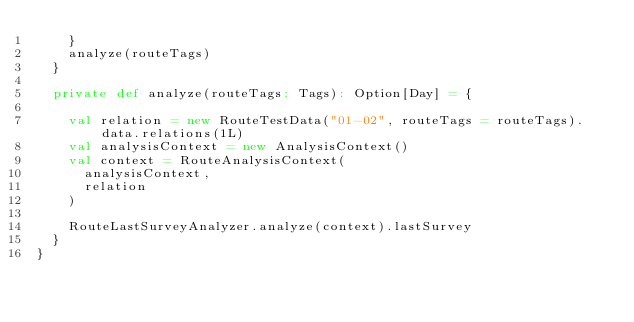Convert code to text. <code><loc_0><loc_0><loc_500><loc_500><_Scala_>    }
    analyze(routeTags)
  }

  private def analyze(routeTags: Tags): Option[Day] = {

    val relation = new RouteTestData("01-02", routeTags = routeTags).data.relations(1L)
    val analysisContext = new AnalysisContext()
    val context = RouteAnalysisContext(
      analysisContext,
      relation
    )

    RouteLastSurveyAnalyzer.analyze(context).lastSurvey
  }
}
</code> 